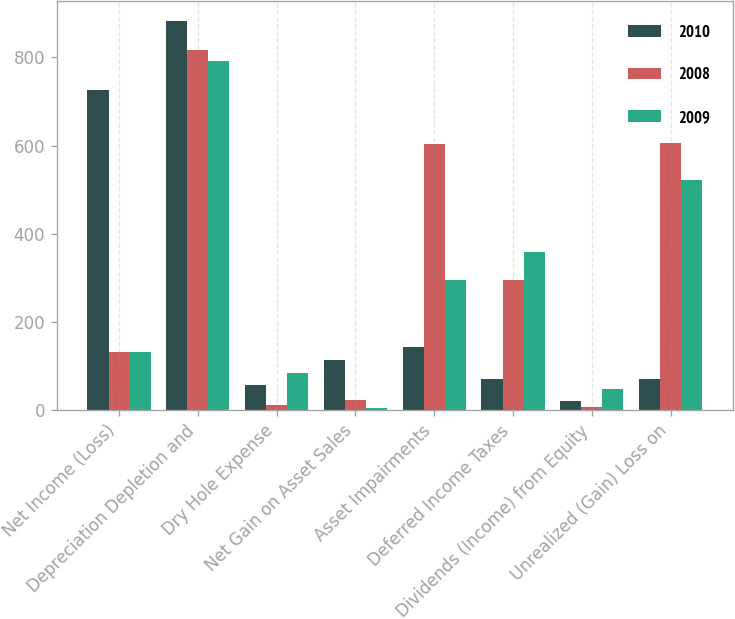<chart> <loc_0><loc_0><loc_500><loc_500><stacked_bar_chart><ecel><fcel>Net Income (Loss)<fcel>Depreciation Depletion and<fcel>Dry Hole Expense<fcel>Net Gain on Asset Sales<fcel>Asset Impairments<fcel>Deferred Income Taxes<fcel>Dividends (Income) from Equity<fcel>Unrealized (Gain) Loss on<nl><fcel>2010<fcel>725<fcel>883<fcel>58<fcel>113<fcel>144<fcel>71<fcel>21<fcel>70<nl><fcel>2008<fcel>131<fcel>816<fcel>11<fcel>22<fcel>604<fcel>296<fcel>8<fcel>606<nl><fcel>2009<fcel>131<fcel>791<fcel>84<fcel>5<fcel>294<fcel>359<fcel>47<fcel>522<nl></chart> 